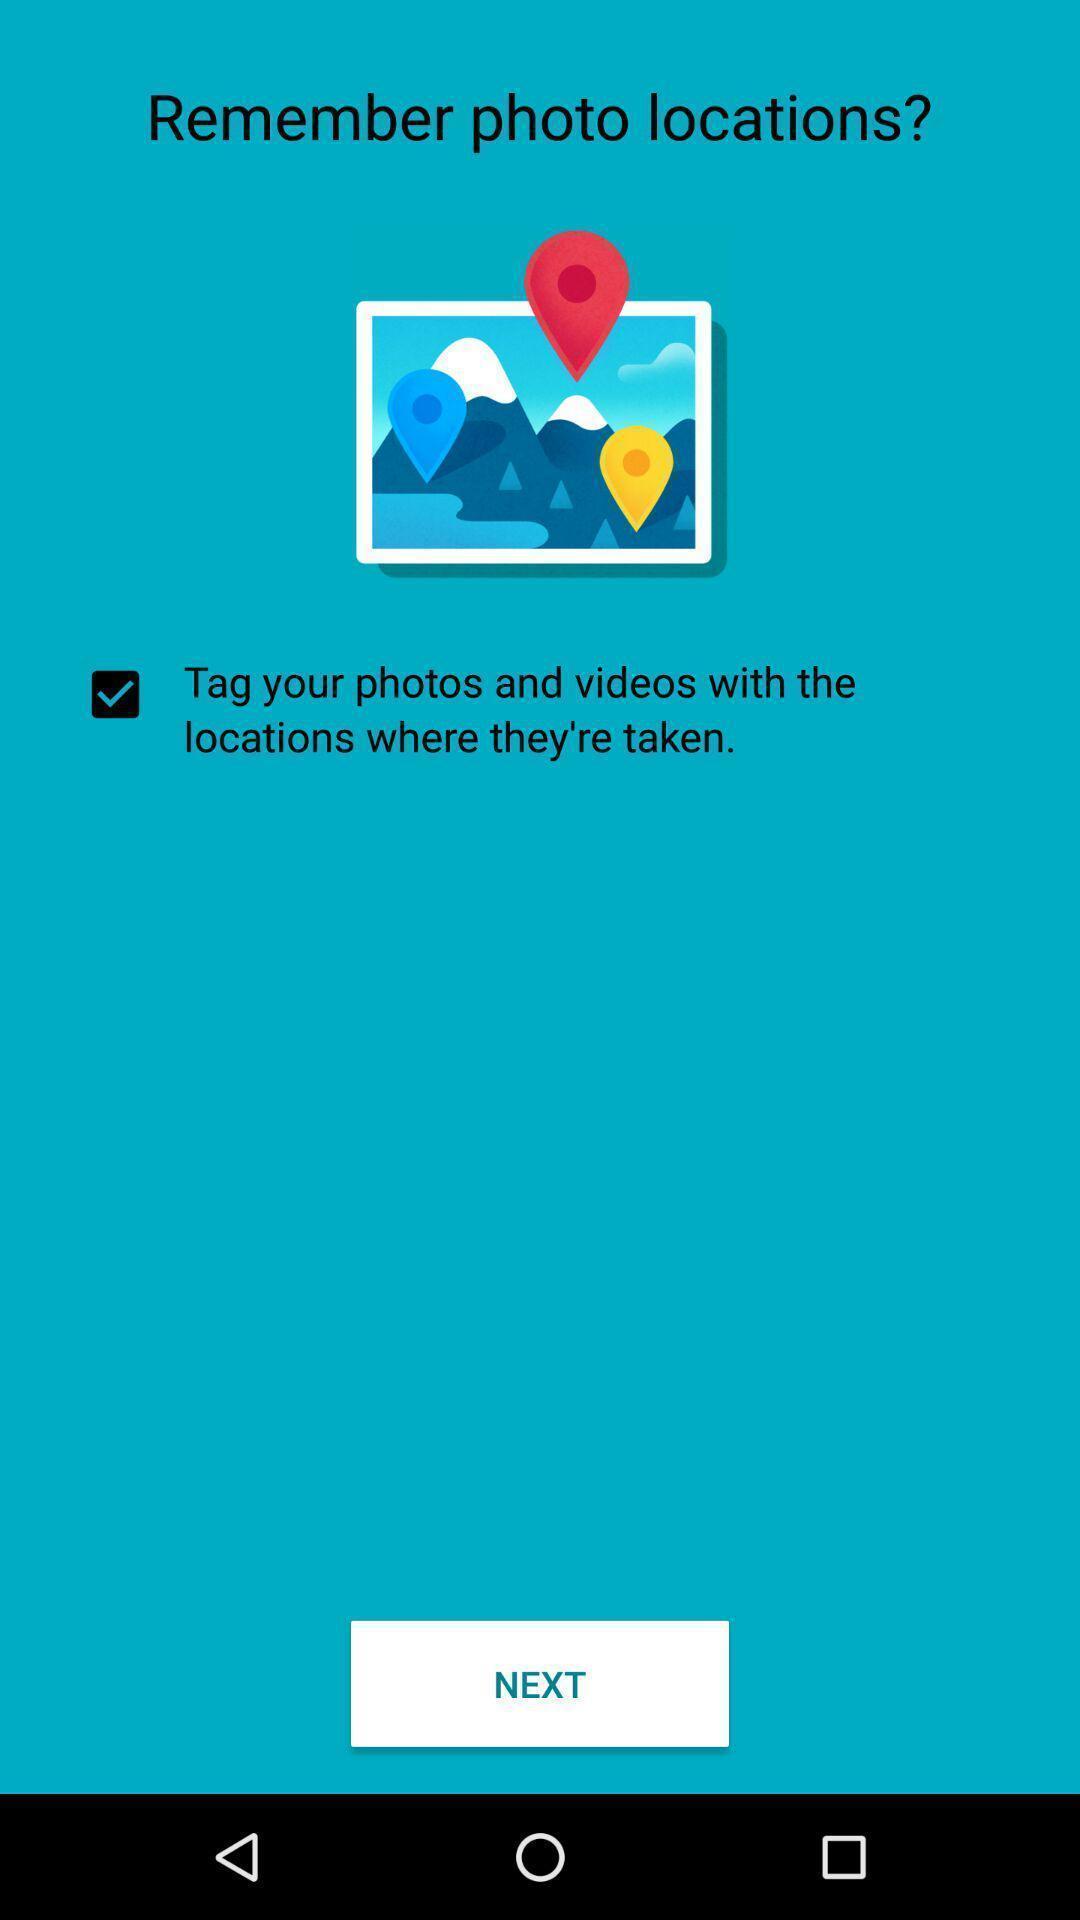Describe the key features of this screenshot. Screen displaying features of a navigation application. 